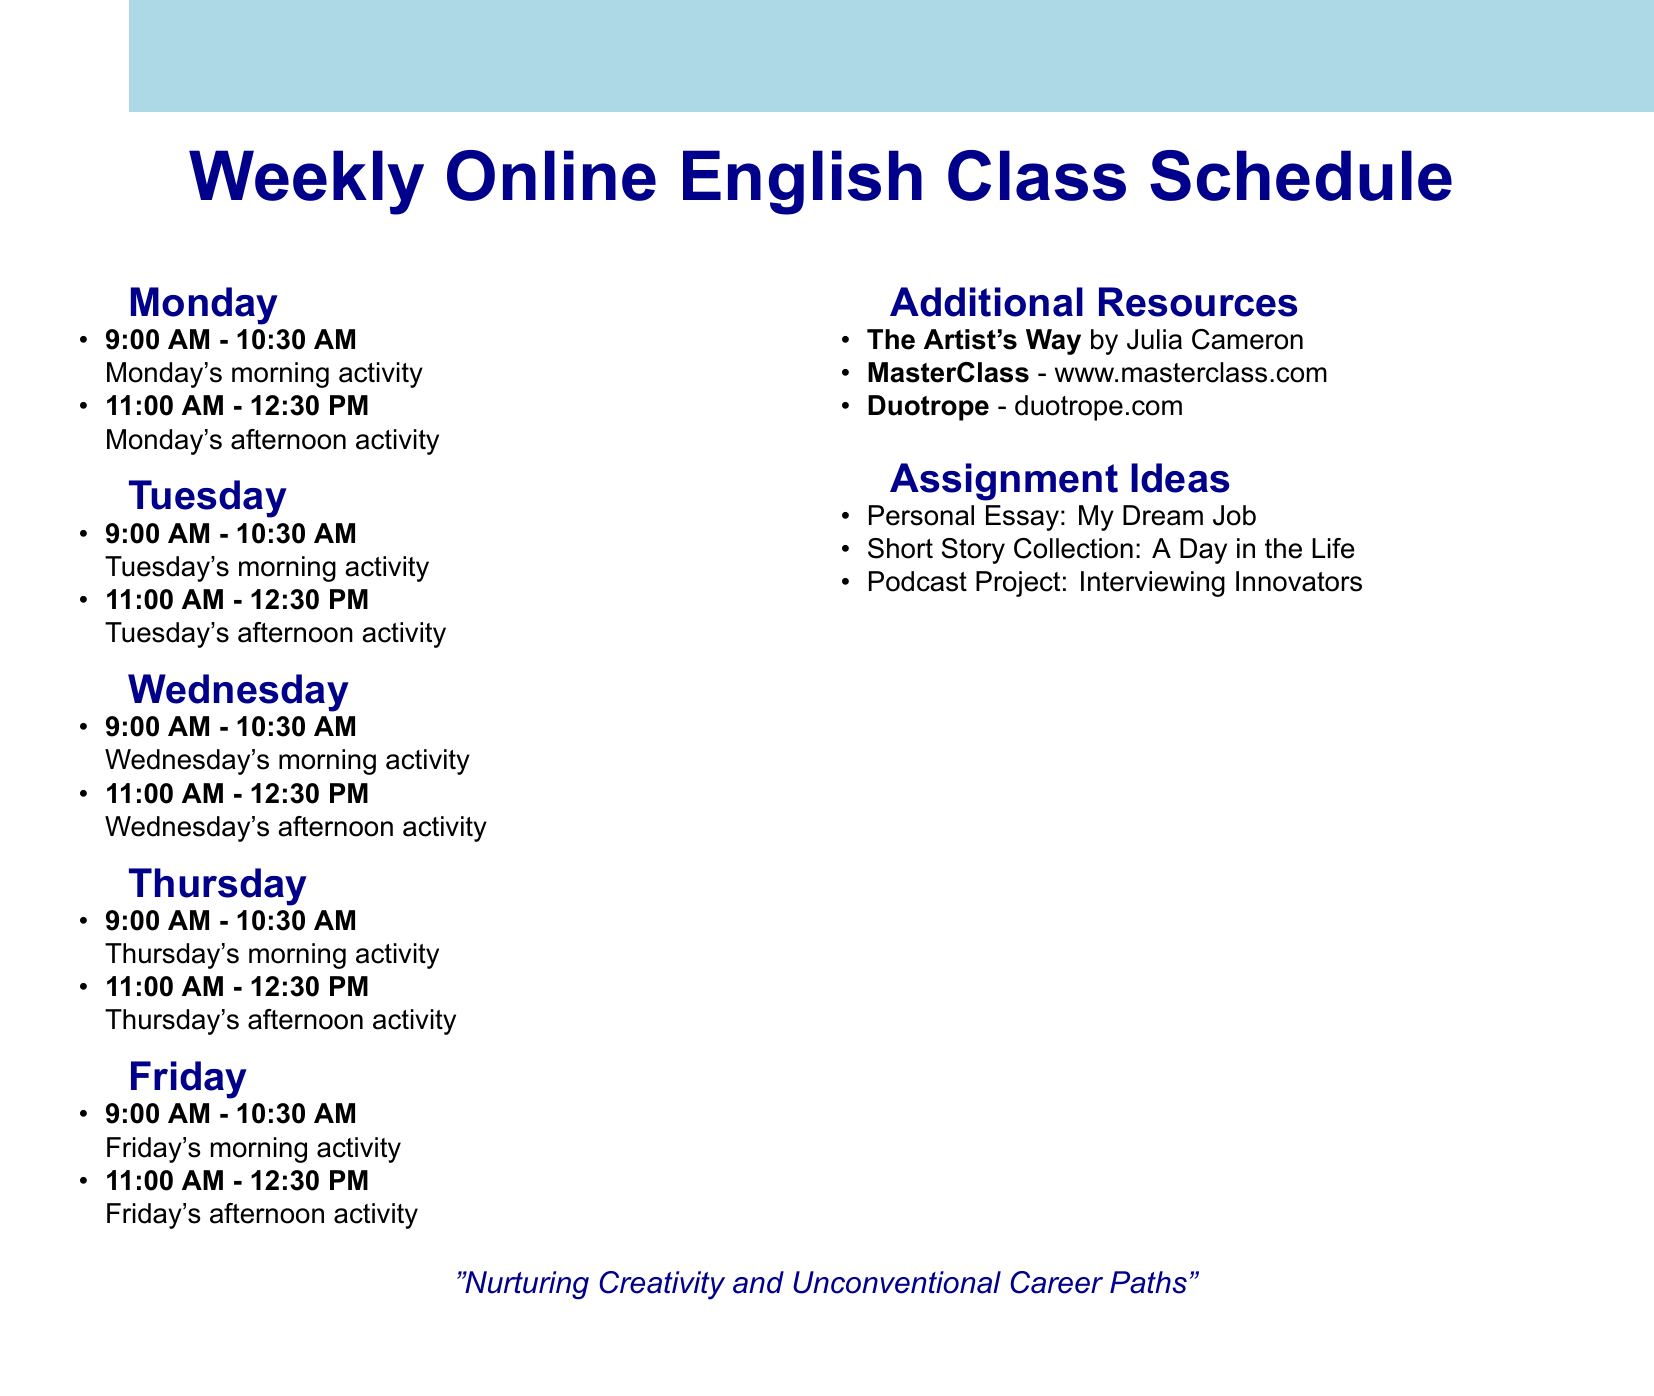what is the title of the Monday morning activity? The title of the Monday morning activity is the first listed activity for Monday, which focuses on grammar.
Answer: Grammar Focus: Conditionals who is the guest speaker on Tuesday? The guest speaker for Tuesday's afternoon activity is mentioned in the schedule.
Answer: Sarah Jenkins what time does the Wednesday afternoon activity start? The starting time for the Wednesday afternoon activity is explicitly stated in the document.
Answer: 11:00 AM how many unconventional career spotlights are there in total? The document lists unconventional career spotlights across two days, which can be summed up.
Answer: 2 what type of writing is introduced on Friday? The document details the specific writing type taught during the Friday morning activity.
Answer: Screenwriting Basics what is the total number of days listed in the schedule? The document outlines activities for each weekday, which sums up to the total.
Answer: 5 what thematic book is discussed on Thursday? The document includes a specific book title analyzed during the Thursday morning activity.
Answer: The Alchemist which resource is recommended for overcoming creative blocks? The document highlights a particular book aimed at nurturing creativity.
Answer: The Artist's Way 